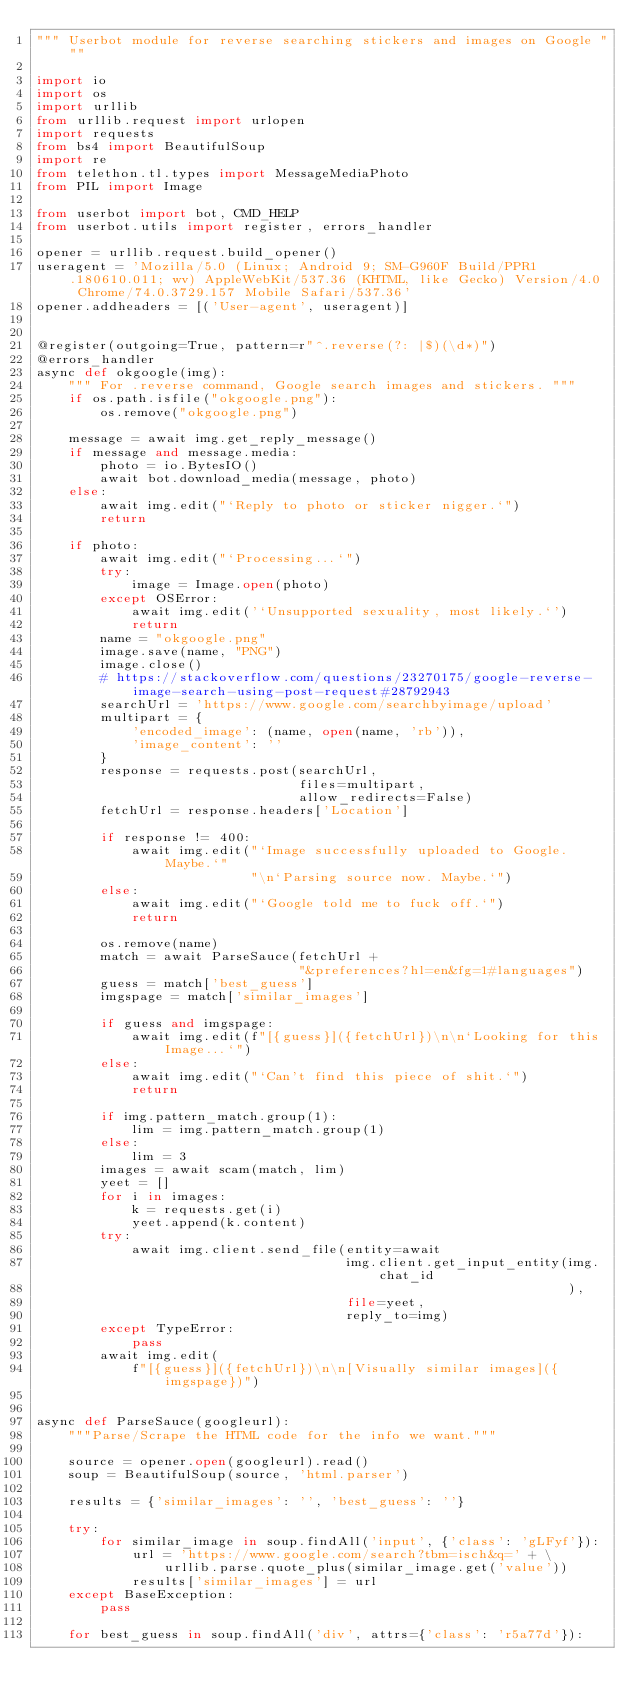<code> <loc_0><loc_0><loc_500><loc_500><_Python_>""" Userbot module for reverse searching stickers and images on Google """

import io
import os
import urllib
from urllib.request import urlopen
import requests
from bs4 import BeautifulSoup
import re
from telethon.tl.types import MessageMediaPhoto
from PIL import Image

from userbot import bot, CMD_HELP
from userbot.utils import register, errors_handler

opener = urllib.request.build_opener()
useragent = 'Mozilla/5.0 (Linux; Android 9; SM-G960F Build/PPR1.180610.011; wv) AppleWebKit/537.36 (KHTML, like Gecko) Version/4.0 Chrome/74.0.3729.157 Mobile Safari/537.36'
opener.addheaders = [('User-agent', useragent)]


@register(outgoing=True, pattern=r"^.reverse(?: |$)(\d*)")
@errors_handler
async def okgoogle(img):
    """ For .reverse command, Google search images and stickers. """
    if os.path.isfile("okgoogle.png"):
        os.remove("okgoogle.png")

    message = await img.get_reply_message()
    if message and message.media:
        photo = io.BytesIO()
        await bot.download_media(message, photo)
    else:
        await img.edit("`Reply to photo or sticker nigger.`")
        return

    if photo:
        await img.edit("`Processing...`")
        try:
            image = Image.open(photo)
        except OSError:
            await img.edit('`Unsupported sexuality, most likely.`')
            return
        name = "okgoogle.png"
        image.save(name, "PNG")
        image.close()
        # https://stackoverflow.com/questions/23270175/google-reverse-image-search-using-post-request#28792943
        searchUrl = 'https://www.google.com/searchbyimage/upload'
        multipart = {
            'encoded_image': (name, open(name, 'rb')),
            'image_content': ''
        }
        response = requests.post(searchUrl,
                                 files=multipart,
                                 allow_redirects=False)
        fetchUrl = response.headers['Location']

        if response != 400:
            await img.edit("`Image successfully uploaded to Google. Maybe.`"
                           "\n`Parsing source now. Maybe.`")
        else:
            await img.edit("`Google told me to fuck off.`")
            return

        os.remove(name)
        match = await ParseSauce(fetchUrl +
                                 "&preferences?hl=en&fg=1#languages")
        guess = match['best_guess']
        imgspage = match['similar_images']

        if guess and imgspage:
            await img.edit(f"[{guess}]({fetchUrl})\n\n`Looking for this Image...`")
        else:
            await img.edit("`Can't find this piece of shit.`")
            return

        if img.pattern_match.group(1):
            lim = img.pattern_match.group(1)
        else:
            lim = 3
        images = await scam(match, lim)
        yeet = []
        for i in images:
            k = requests.get(i)
            yeet.append(k.content)
        try:
            await img.client.send_file(entity=await
                                       img.client.get_input_entity(img.chat_id
                                                                   ),
                                       file=yeet,
                                       reply_to=img)
        except TypeError:
            pass
        await img.edit(
            f"[{guess}]({fetchUrl})\n\n[Visually similar images]({imgspage})")


async def ParseSauce(googleurl):
    """Parse/Scrape the HTML code for the info we want."""

    source = opener.open(googleurl).read()
    soup = BeautifulSoup(source, 'html.parser')

    results = {'similar_images': '', 'best_guess': ''}

    try:
        for similar_image in soup.findAll('input', {'class': 'gLFyf'}):
            url = 'https://www.google.com/search?tbm=isch&q=' + \
                urllib.parse.quote_plus(similar_image.get('value'))
            results['similar_images'] = url
    except BaseException:
        pass

    for best_guess in soup.findAll('div', attrs={'class': 'r5a77d'}):</code> 